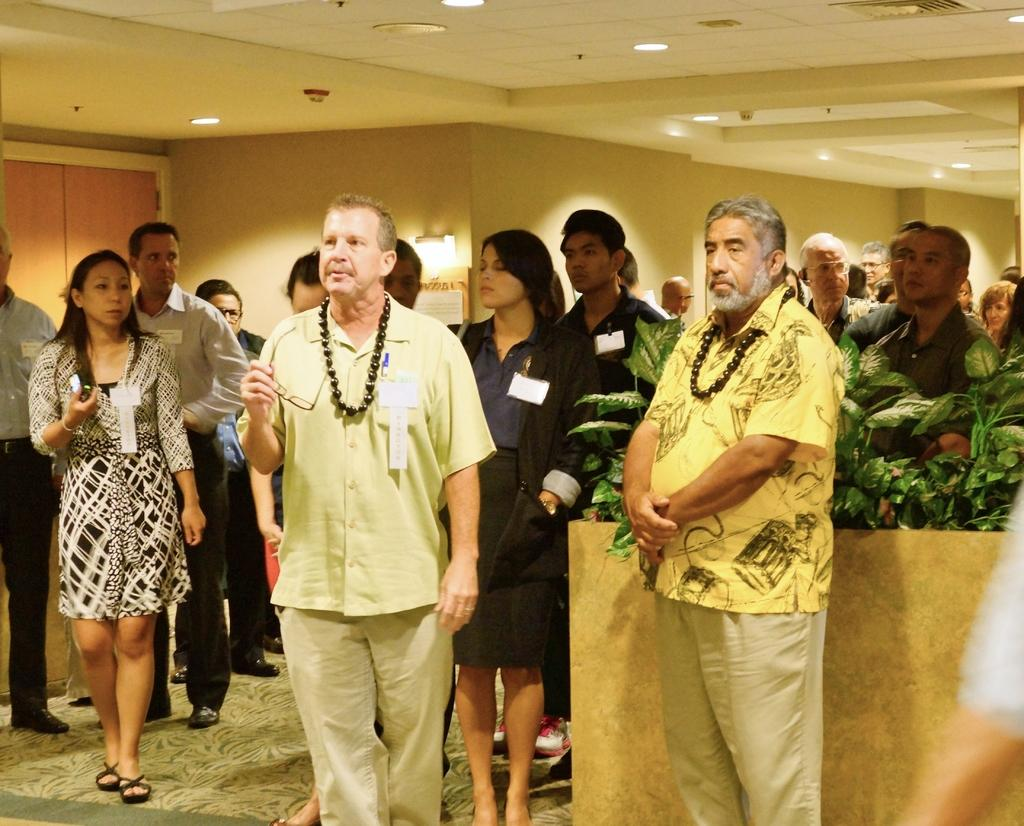How many people are present in the image? There are a few people in the image. What can be seen beneath the people's feet in the image? The ground is visible in the image. What type of vegetation is present in the image? There are plants in the image. What object can be seen in the image that might be used for displaying information or messages? There is a board in the image. What type of structure is visible in the image? There is a wall in the image. What material is visible in the image that is commonly used in construction or furniture? There is some wood visible in the image. What can be seen on the roof in the image? There are lights on the roof in the image. How many children are playing with quartz in the image? There are no children or quartz present in the image. What type of business is being conducted in the image? The image does not depict any business activities. 